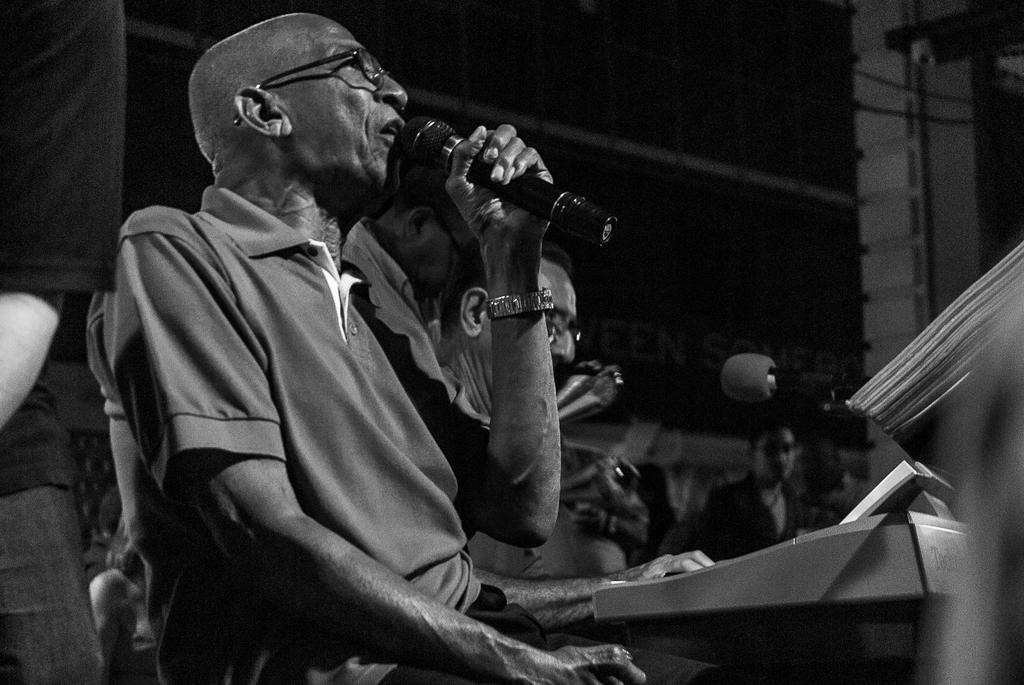What is the color scheme of the image? The image is black and white. Who is present in the image? There is a man in the image. What is the man doing in the image? The man is talking on a microphone. What accessory is the man wearing in the image? The man is wearing spectacles. What type of bomb is the man trying to smash in the image? There is no bomb present in the image; the man is talking on a microphone and wearing spectacles. 